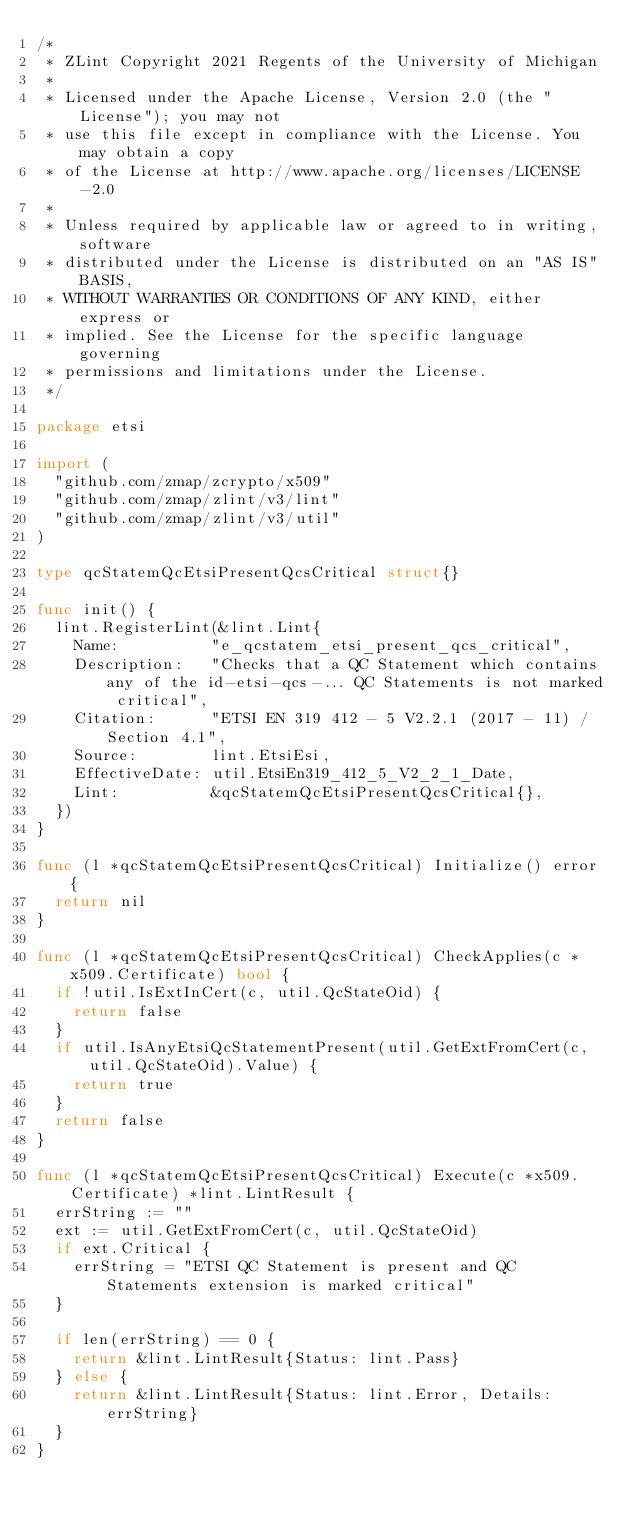<code> <loc_0><loc_0><loc_500><loc_500><_Go_>/*
 * ZLint Copyright 2021 Regents of the University of Michigan
 *
 * Licensed under the Apache License, Version 2.0 (the "License"); you may not
 * use this file except in compliance with the License. You may obtain a copy
 * of the License at http://www.apache.org/licenses/LICENSE-2.0
 *
 * Unless required by applicable law or agreed to in writing, software
 * distributed under the License is distributed on an "AS IS" BASIS,
 * WITHOUT WARRANTIES OR CONDITIONS OF ANY KIND, either express or
 * implied. See the License for the specific language governing
 * permissions and limitations under the License.
 */

package etsi

import (
	"github.com/zmap/zcrypto/x509"
	"github.com/zmap/zlint/v3/lint"
	"github.com/zmap/zlint/v3/util"
)

type qcStatemQcEtsiPresentQcsCritical struct{}

func init() {
	lint.RegisterLint(&lint.Lint{
		Name:          "e_qcstatem_etsi_present_qcs_critical",
		Description:   "Checks that a QC Statement which contains any of the id-etsi-qcs-... QC Statements is not marked critical",
		Citation:      "ETSI EN 319 412 - 5 V2.2.1 (2017 - 11) / Section 4.1",
		Source:        lint.EtsiEsi,
		EffectiveDate: util.EtsiEn319_412_5_V2_2_1_Date,
		Lint:          &qcStatemQcEtsiPresentQcsCritical{},
	})
}

func (l *qcStatemQcEtsiPresentQcsCritical) Initialize() error {
	return nil
}

func (l *qcStatemQcEtsiPresentQcsCritical) CheckApplies(c *x509.Certificate) bool {
	if !util.IsExtInCert(c, util.QcStateOid) {
		return false
	}
	if util.IsAnyEtsiQcStatementPresent(util.GetExtFromCert(c, util.QcStateOid).Value) {
		return true
	}
	return false
}

func (l *qcStatemQcEtsiPresentQcsCritical) Execute(c *x509.Certificate) *lint.LintResult {
	errString := ""
	ext := util.GetExtFromCert(c, util.QcStateOid)
	if ext.Critical {
		errString = "ETSI QC Statement is present and QC Statements extension is marked critical"
	}

	if len(errString) == 0 {
		return &lint.LintResult{Status: lint.Pass}
	} else {
		return &lint.LintResult{Status: lint.Error, Details: errString}
	}
}
</code> 